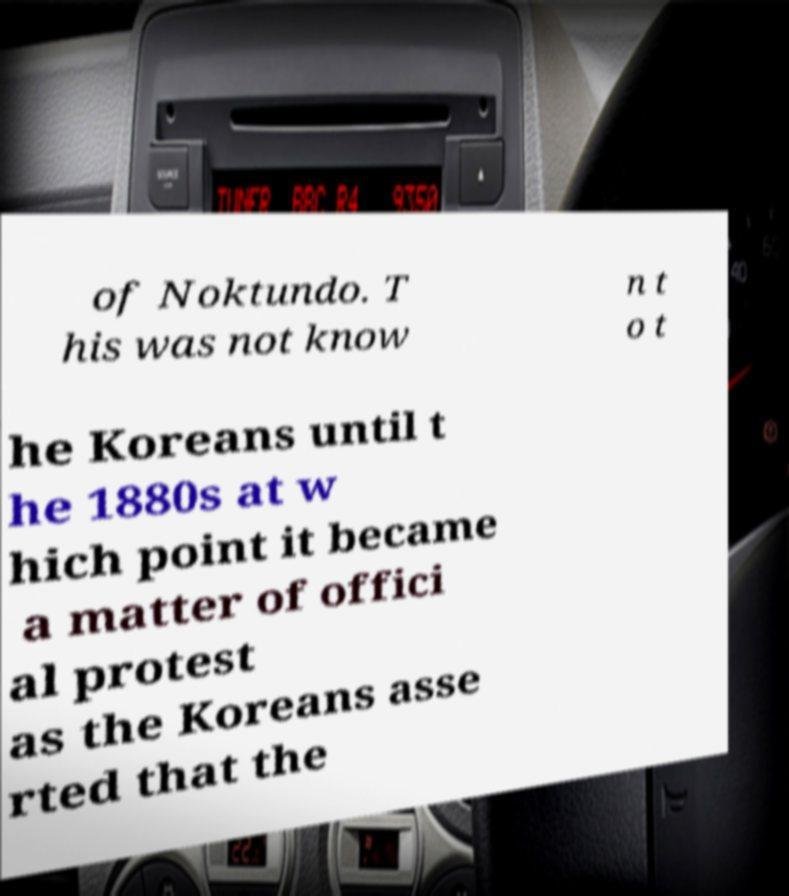Can you read and provide the text displayed in the image?This photo seems to have some interesting text. Can you extract and type it out for me? of Noktundo. T his was not know n t o t he Koreans until t he 1880s at w hich point it became a matter of offici al protest as the Koreans asse rted that the 